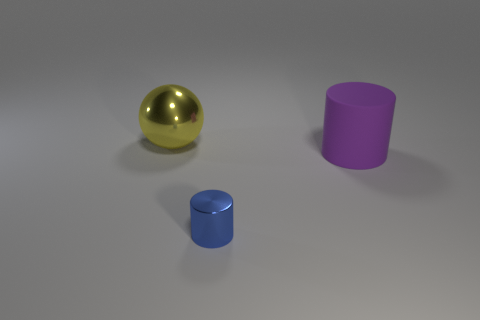Add 2 large metal balls. How many objects exist? 5 Subtract all cylinders. How many objects are left? 1 Add 1 big blue cubes. How many big blue cubes exist? 1 Subtract 0 green blocks. How many objects are left? 3 Subtract all tiny gray metallic cylinders. Subtract all tiny blue cylinders. How many objects are left? 2 Add 2 big purple rubber cylinders. How many big purple rubber cylinders are left? 3 